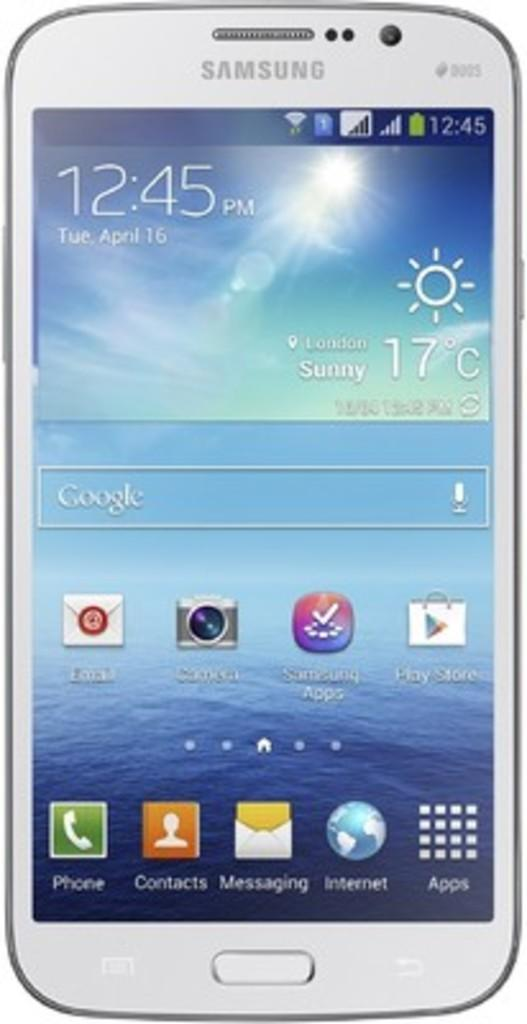<image>
Provide a brief description of the given image. A samsung smart phone open to its home page. 